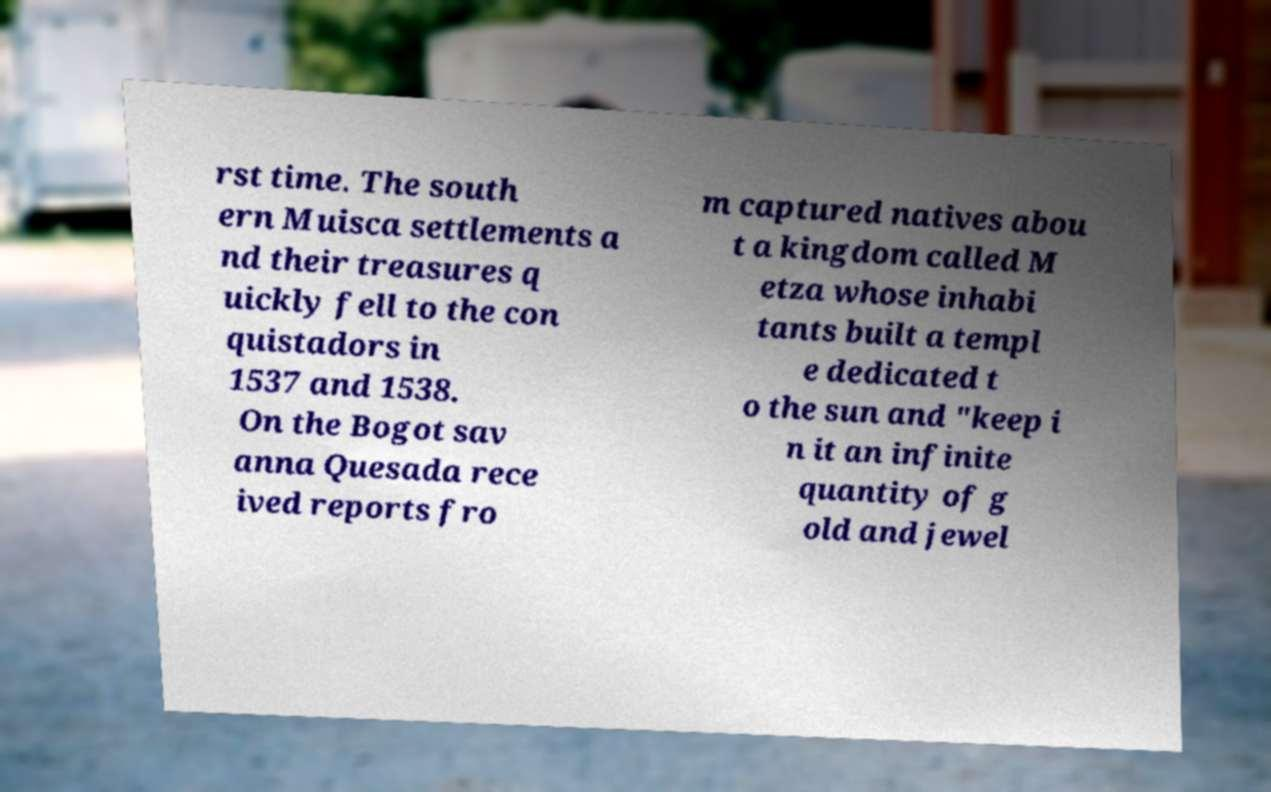What messages or text are displayed in this image? I need them in a readable, typed format. rst time. The south ern Muisca settlements a nd their treasures q uickly fell to the con quistadors in 1537 and 1538. On the Bogot sav anna Quesada rece ived reports fro m captured natives abou t a kingdom called M etza whose inhabi tants built a templ e dedicated t o the sun and "keep i n it an infinite quantity of g old and jewel 